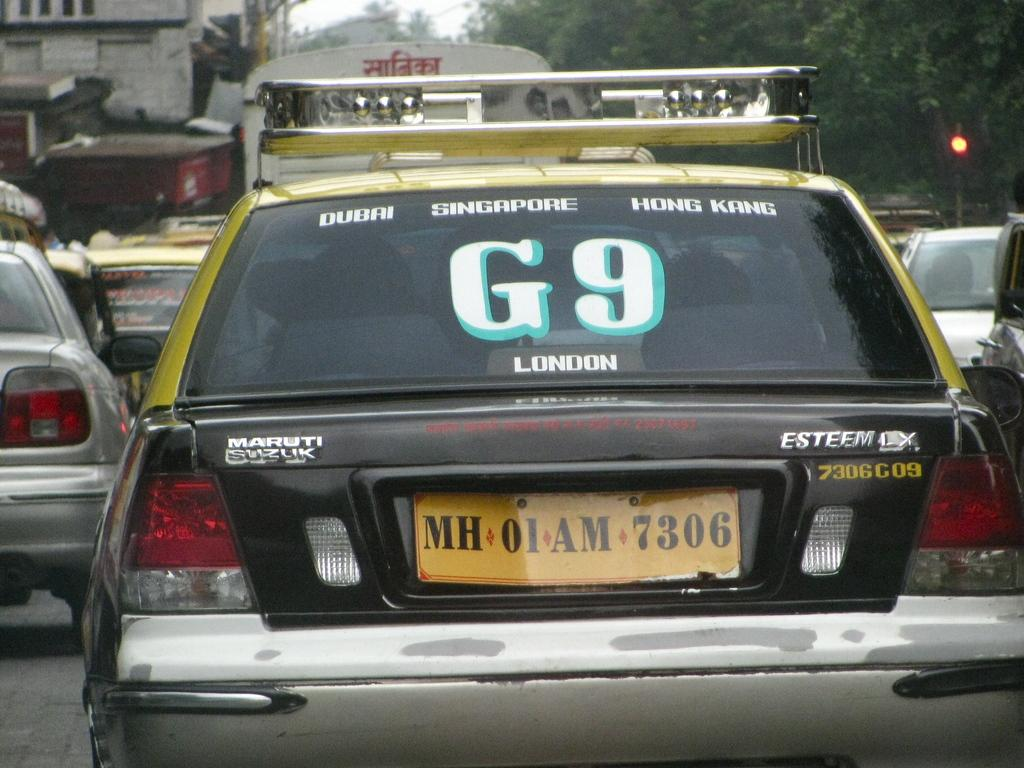<image>
Give a short and clear explanation of the subsequent image. A car has G9 in white and green outlines on the back window. 